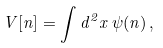Convert formula to latex. <formula><loc_0><loc_0><loc_500><loc_500>V [ n ] = \int d ^ { 2 } x \, \psi ( n ) \, ,</formula> 